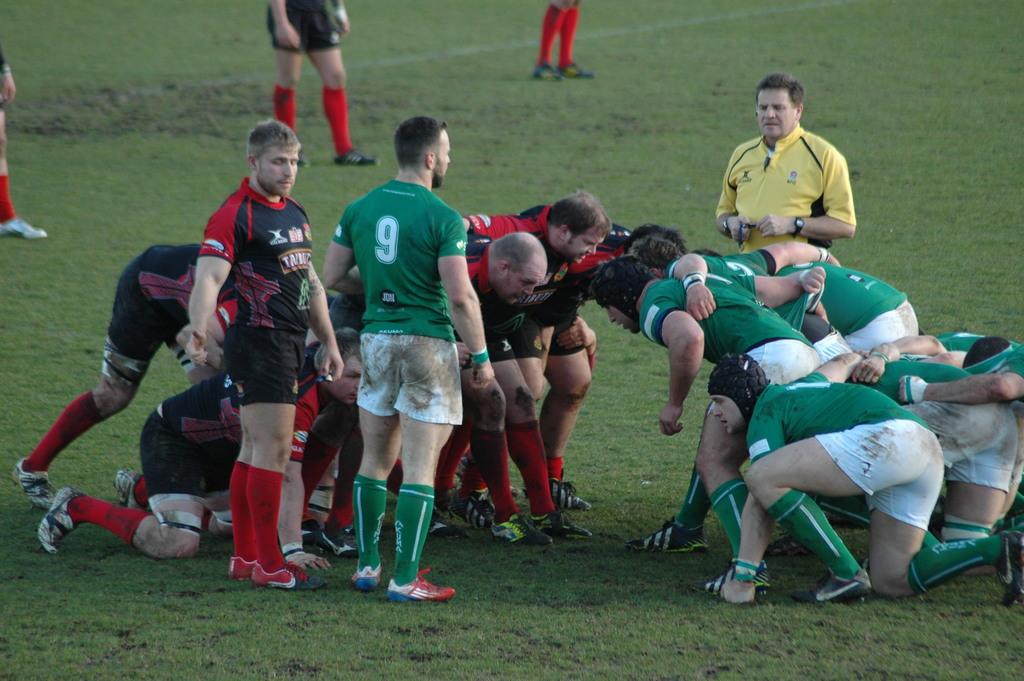What is the main subject of the image? The main subject of the image is a group of people. Where are the people located in the image? The people are on the ground in the image. What colors are the people wearing in the image? The people are wearing various colors, including green, white, black, red, yellow, and black. What type of insect can be seen crawling on the people in the image? There is no insect present in the image; it only features a group of people on the ground. 